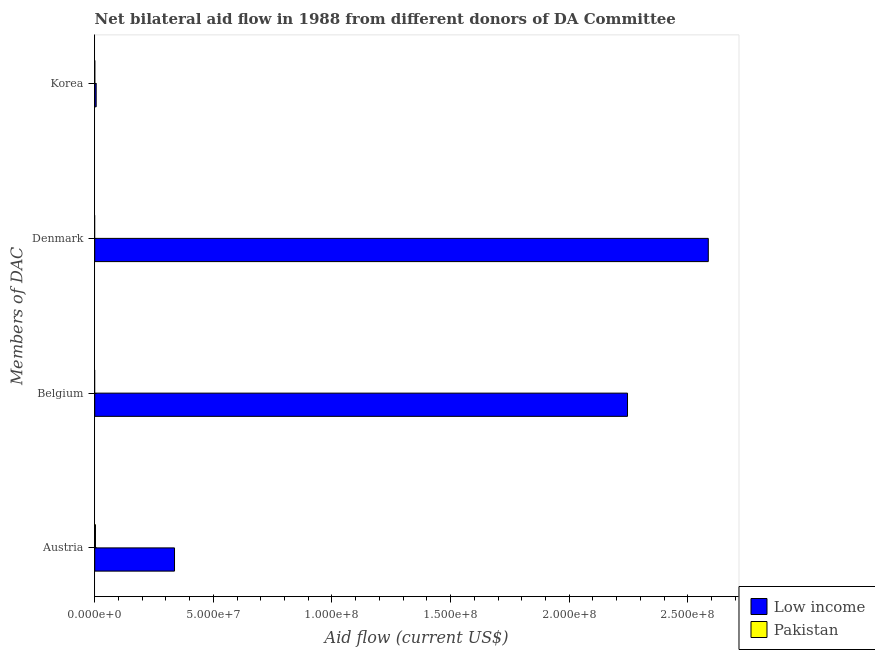How many different coloured bars are there?
Offer a terse response. 2. Are the number of bars on each tick of the Y-axis equal?
Your answer should be compact. No. How many bars are there on the 1st tick from the top?
Your answer should be very brief. 2. How many bars are there on the 2nd tick from the bottom?
Offer a terse response. 1. What is the label of the 2nd group of bars from the top?
Keep it short and to the point. Denmark. What is the amount of aid given by austria in Low income?
Offer a very short reply. 3.36e+07. Across all countries, what is the maximum amount of aid given by korea?
Make the answer very short. 6.10e+05. Across all countries, what is the minimum amount of aid given by austria?
Your answer should be very brief. 3.10e+05. What is the total amount of aid given by belgium in the graph?
Provide a succinct answer. 2.25e+08. What is the difference between the amount of aid given by austria in Pakistan and that in Low income?
Make the answer very short. -3.33e+07. What is the difference between the amount of aid given by austria in Low income and the amount of aid given by korea in Pakistan?
Give a very brief answer. 3.36e+07. What is the average amount of aid given by denmark per country?
Your answer should be compact. 1.29e+08. What is the difference between the amount of aid given by belgium and amount of aid given by korea in Low income?
Your answer should be compact. 2.24e+08. What is the ratio of the amount of aid given by austria in Low income to that in Pakistan?
Keep it short and to the point. 108.48. Is the amount of aid given by austria in Pakistan less than that in Low income?
Offer a very short reply. Yes. What is the difference between the highest and the lowest amount of aid given by denmark?
Ensure brevity in your answer.  2.59e+08. In how many countries, is the amount of aid given by korea greater than the average amount of aid given by korea taken over all countries?
Offer a very short reply. 1. Is the sum of the amount of aid given by austria in Pakistan and Low income greater than the maximum amount of aid given by belgium across all countries?
Your response must be concise. No. Is it the case that in every country, the sum of the amount of aid given by belgium and amount of aid given by denmark is greater than the sum of amount of aid given by korea and amount of aid given by austria?
Make the answer very short. No. Are all the bars in the graph horizontal?
Provide a succinct answer. Yes. What is the difference between two consecutive major ticks on the X-axis?
Your answer should be compact. 5.00e+07. Are the values on the major ticks of X-axis written in scientific E-notation?
Your answer should be compact. Yes. Does the graph contain grids?
Offer a terse response. No. Where does the legend appear in the graph?
Make the answer very short. Bottom right. How many legend labels are there?
Your answer should be compact. 2. How are the legend labels stacked?
Your answer should be very brief. Vertical. What is the title of the graph?
Provide a succinct answer. Net bilateral aid flow in 1988 from different donors of DA Committee. What is the label or title of the Y-axis?
Provide a succinct answer. Members of DAC. What is the Aid flow (current US$) of Low income in Austria?
Offer a very short reply. 3.36e+07. What is the Aid flow (current US$) of Low income in Belgium?
Your answer should be very brief. 2.25e+08. What is the Aid flow (current US$) of Pakistan in Belgium?
Your answer should be very brief. 0. What is the Aid flow (current US$) in Low income in Denmark?
Keep it short and to the point. 2.59e+08. Across all Members of DAC, what is the maximum Aid flow (current US$) in Low income?
Your answer should be compact. 2.59e+08. Across all Members of DAC, what is the maximum Aid flow (current US$) in Pakistan?
Your response must be concise. 3.10e+05. Across all Members of DAC, what is the minimum Aid flow (current US$) in Low income?
Offer a terse response. 6.10e+05. What is the total Aid flow (current US$) of Low income in the graph?
Give a very brief answer. 5.17e+08. What is the total Aid flow (current US$) in Pakistan in the graph?
Provide a short and direct response. 3.20e+05. What is the difference between the Aid flow (current US$) of Low income in Austria and that in Belgium?
Keep it short and to the point. -1.91e+08. What is the difference between the Aid flow (current US$) in Low income in Austria and that in Denmark?
Your response must be concise. -2.25e+08. What is the difference between the Aid flow (current US$) of Low income in Austria and that in Korea?
Give a very brief answer. 3.30e+07. What is the difference between the Aid flow (current US$) in Low income in Belgium and that in Denmark?
Give a very brief answer. -3.40e+07. What is the difference between the Aid flow (current US$) in Low income in Belgium and that in Korea?
Keep it short and to the point. 2.24e+08. What is the difference between the Aid flow (current US$) of Low income in Denmark and that in Korea?
Give a very brief answer. 2.58e+08. What is the difference between the Aid flow (current US$) of Low income in Austria and the Aid flow (current US$) of Pakistan in Korea?
Offer a terse response. 3.36e+07. What is the difference between the Aid flow (current US$) in Low income in Belgium and the Aid flow (current US$) in Pakistan in Korea?
Offer a very short reply. 2.25e+08. What is the difference between the Aid flow (current US$) in Low income in Denmark and the Aid flow (current US$) in Pakistan in Korea?
Your response must be concise. 2.59e+08. What is the average Aid flow (current US$) of Low income per Members of DAC?
Offer a terse response. 1.29e+08. What is the difference between the Aid flow (current US$) in Low income and Aid flow (current US$) in Pakistan in Austria?
Your answer should be compact. 3.33e+07. What is the difference between the Aid flow (current US$) of Low income and Aid flow (current US$) of Pakistan in Korea?
Keep it short and to the point. 6.00e+05. What is the ratio of the Aid flow (current US$) in Low income in Austria to that in Belgium?
Provide a short and direct response. 0.15. What is the ratio of the Aid flow (current US$) of Low income in Austria to that in Denmark?
Provide a short and direct response. 0.13. What is the ratio of the Aid flow (current US$) in Low income in Austria to that in Korea?
Your answer should be compact. 55.13. What is the ratio of the Aid flow (current US$) in Low income in Belgium to that in Denmark?
Your answer should be compact. 0.87. What is the ratio of the Aid flow (current US$) of Low income in Belgium to that in Korea?
Your answer should be compact. 368.18. What is the ratio of the Aid flow (current US$) in Low income in Denmark to that in Korea?
Your answer should be compact. 424. What is the difference between the highest and the second highest Aid flow (current US$) of Low income?
Your answer should be compact. 3.40e+07. What is the difference between the highest and the lowest Aid flow (current US$) of Low income?
Offer a very short reply. 2.58e+08. What is the difference between the highest and the lowest Aid flow (current US$) of Pakistan?
Provide a short and direct response. 3.10e+05. 